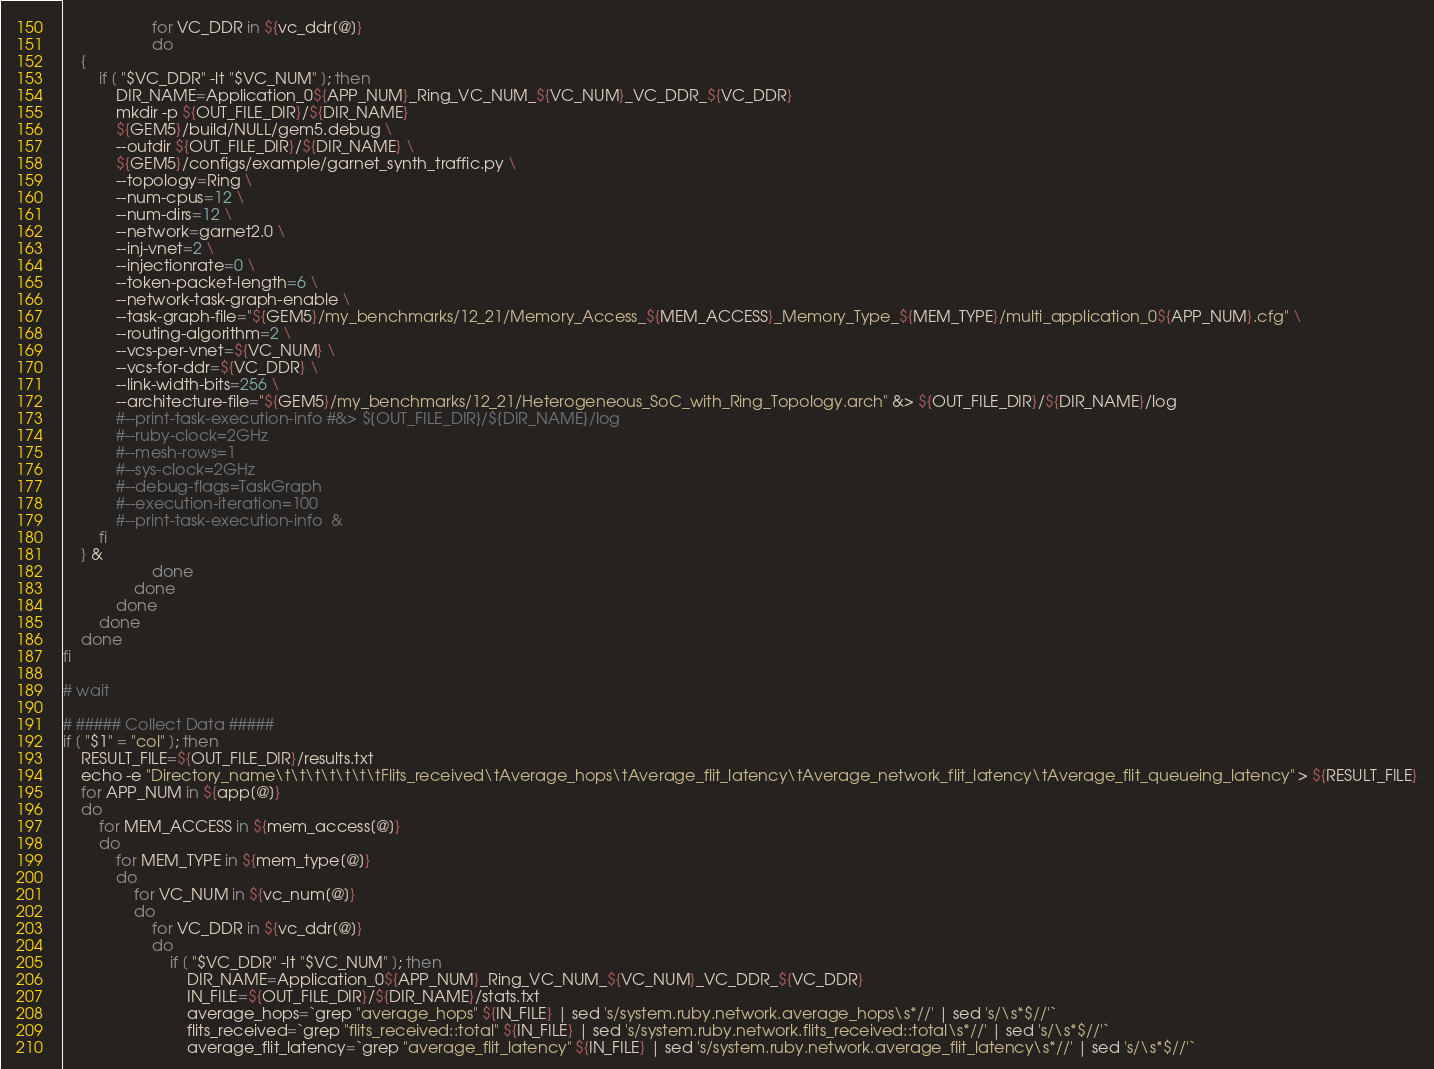<code> <loc_0><loc_0><loc_500><loc_500><_Bash_>                    for VC_DDR in ${vc_ddr[@]}
                    do
    {
        if [ "$VC_DDR" -lt "$VC_NUM" ]; then
            DIR_NAME=Application_0${APP_NUM}_Ring_VC_NUM_${VC_NUM}_VC_DDR_${VC_DDR}
            mkdir -p ${OUT_FILE_DIR}/${DIR_NAME}  
            ${GEM5}/build/NULL/gem5.debug \
            --outdir ${OUT_FILE_DIR}/${DIR_NAME} \
            ${GEM5}/configs/example/garnet_synth_traffic.py \
            --topology=Ring \
            --num-cpus=12 \
            --num-dirs=12 \
            --network=garnet2.0 \
            --inj-vnet=2 \
            --injectionrate=0 \
            --token-packet-length=6 \
            --network-task-graph-enable \
            --task-graph-file="${GEM5}/my_benchmarks/12_21/Memory_Access_${MEM_ACCESS}_Memory_Type_${MEM_TYPE}/multi_application_0${APP_NUM}.cfg" \
            --routing-algorithm=2 \
            --vcs-per-vnet=${VC_NUM} \
            --vcs-for-ddr=${VC_DDR} \
            --link-width-bits=256 \
            --architecture-file="${GEM5}/my_benchmarks/12_21/Heterogeneous_SoC_with_Ring_Topology.arch" &> ${OUT_FILE_DIR}/${DIR_NAME}/log
            #--print-task-execution-info #&> ${OUT_FILE_DIR}/${DIR_NAME}/log  
            #--ruby-clock=2GHz
            #--mesh-rows=1
            #--sys-clock=2GHz
            #--debug-flags=TaskGraph
            #--execution-iteration=100
            #--print-task-execution-info  &
        fi
    } &
                    done
                done
            done
        done
    done
fi

# wait 

# ##### Collect Data #####
if [ "$1" = "col" ]; then
    RESULT_FILE=${OUT_FILE_DIR}/results.txt
    echo -e "Directory_name\t\t\t\t\t\t\tFlits_received\tAverage_hops\tAverage_flit_latency\tAverage_network_flit_latency\tAverage_flit_queueing_latency" > ${RESULT_FILE}
    for APP_NUM in ${app[@]}
    do
        for MEM_ACCESS in ${mem_access[@]}
        do
            for MEM_TYPE in ${mem_type[@]}
            do
                for VC_NUM in ${vc_num[@]}
                do
                    for VC_DDR in ${vc_ddr[@]}
                    do
                        if [ "$VC_DDR" -lt "$VC_NUM" ]; then
                            DIR_NAME=Application_0${APP_NUM}_Ring_VC_NUM_${VC_NUM}_VC_DDR_${VC_DDR}
                            IN_FILE=${OUT_FILE_DIR}/${DIR_NAME}/stats.txt
                            average_hops=`grep "average_hops" ${IN_FILE} | sed 's/system.ruby.network.average_hops\s*//' | sed 's/\s*$//'`
                            flits_received=`grep "flits_received::total" ${IN_FILE} | sed 's/system.ruby.network.flits_received::total\s*//' | sed 's/\s*$//'`
                            average_flit_latency=`grep "average_flit_latency" ${IN_FILE} | sed 's/system.ruby.network.average_flit_latency\s*//' | sed 's/\s*$//'`</code> 